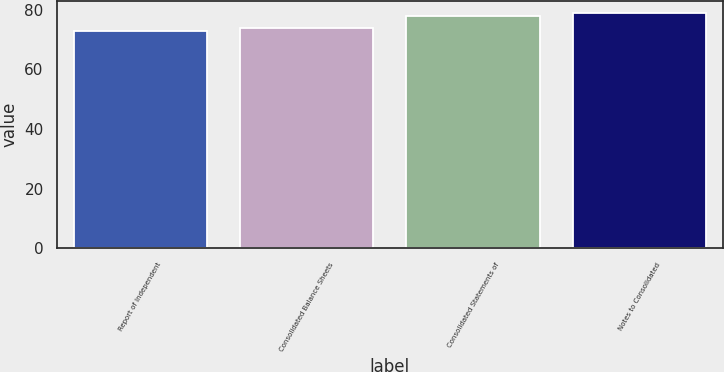<chart> <loc_0><loc_0><loc_500><loc_500><bar_chart><fcel>Report of Independent<fcel>Consolidated Balance Sheets<fcel>Consolidated Statements of<fcel>Notes to Consolidated<nl><fcel>73<fcel>74<fcel>78<fcel>79<nl></chart> 